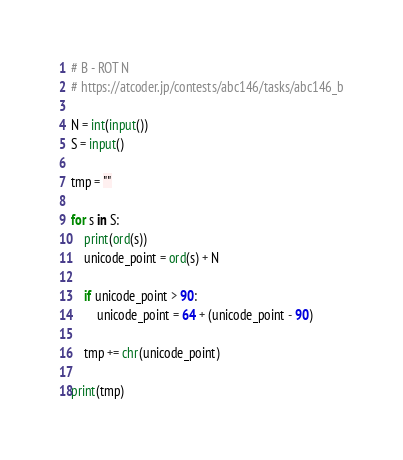<code> <loc_0><loc_0><loc_500><loc_500><_Python_># B - ROT N
# https://atcoder.jp/contests/abc146/tasks/abc146_b

N = int(input())
S = input()

tmp = ""

for s in S:
    print(ord(s))
    unicode_point = ord(s) + N

    if unicode_point > 90:
        unicode_point = 64 + (unicode_point - 90)

    tmp += chr(unicode_point)

print(tmp)</code> 